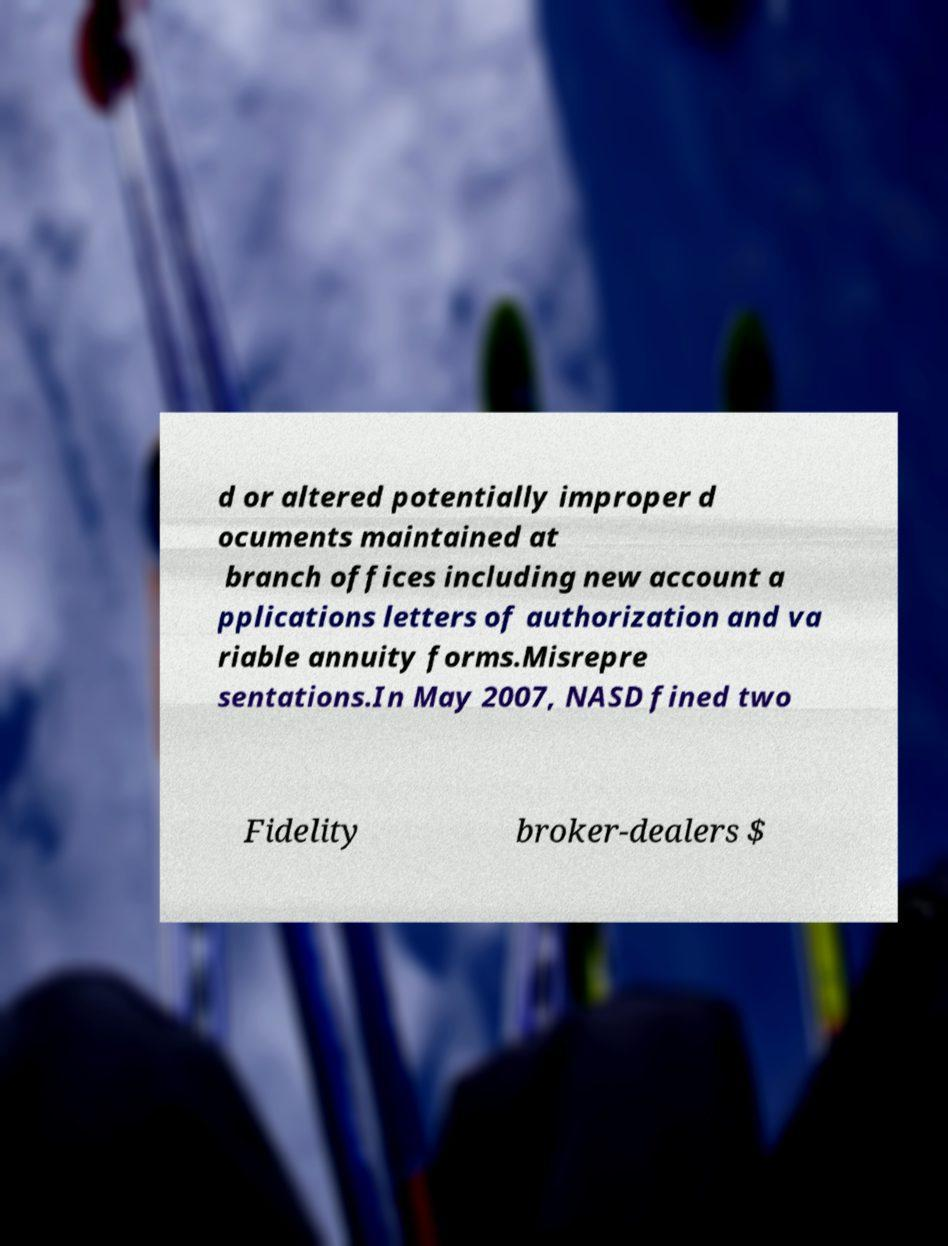Can you read and provide the text displayed in the image?This photo seems to have some interesting text. Can you extract and type it out for me? d or altered potentially improper d ocuments maintained at branch offices including new account a pplications letters of authorization and va riable annuity forms.Misrepre sentations.In May 2007, NASD fined two Fidelity broker-dealers $ 